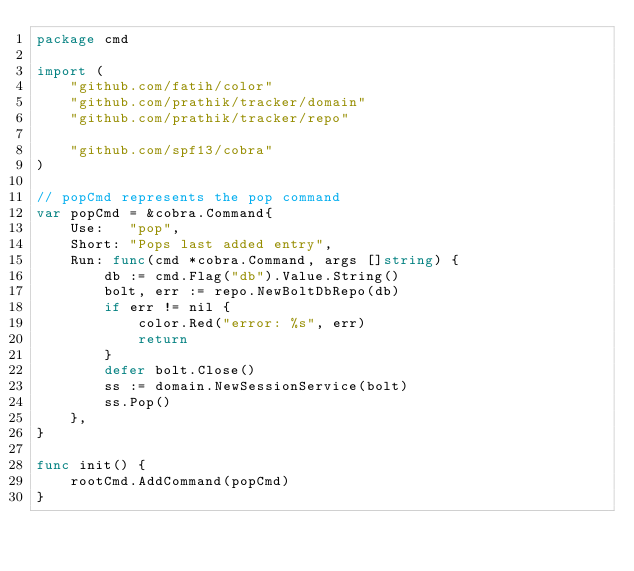Convert code to text. <code><loc_0><loc_0><loc_500><loc_500><_Go_>package cmd

import (
	"github.com/fatih/color"
	"github.com/prathik/tracker/domain"
	"github.com/prathik/tracker/repo"

	"github.com/spf13/cobra"
)

// popCmd represents the pop command
var popCmd = &cobra.Command{
	Use:   "pop",
	Short: "Pops last added entry",
	Run: func(cmd *cobra.Command, args []string) {
		db := cmd.Flag("db").Value.String()
		bolt, err := repo.NewBoltDbRepo(db)
		if err != nil {
			color.Red("error: %s", err)
			return
		}
		defer bolt.Close()
		ss := domain.NewSessionService(bolt)
		ss.Pop()
	},
}

func init() {
	rootCmd.AddCommand(popCmd)
}
</code> 